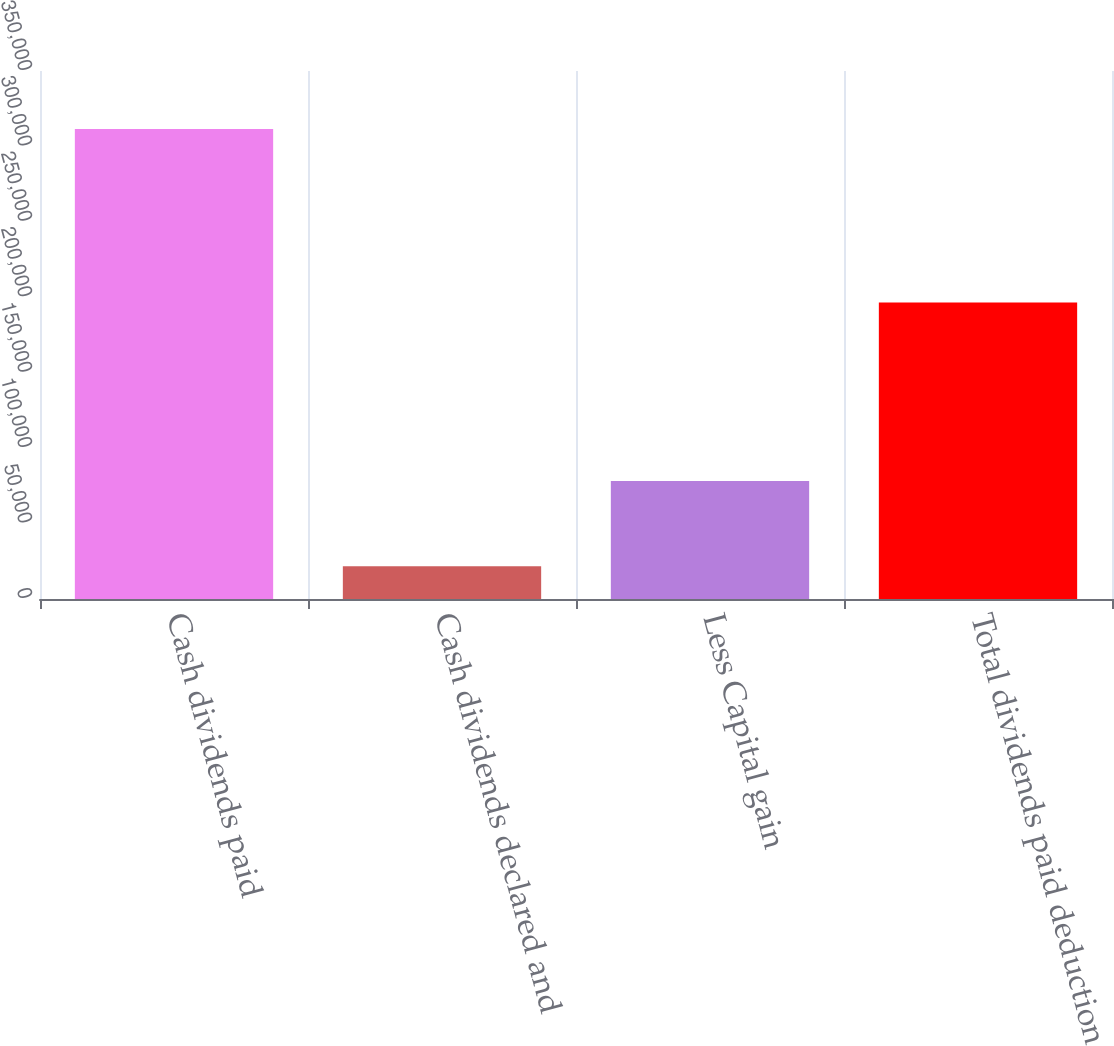Convert chart to OTSL. <chart><loc_0><loc_0><loc_500><loc_500><bar_chart><fcel>Cash dividends paid<fcel>Cash dividends declared and<fcel>Less Capital gain<fcel>Total dividends paid deduction<nl><fcel>311615<fcel>21782<fcel>78246<fcel>196569<nl></chart> 